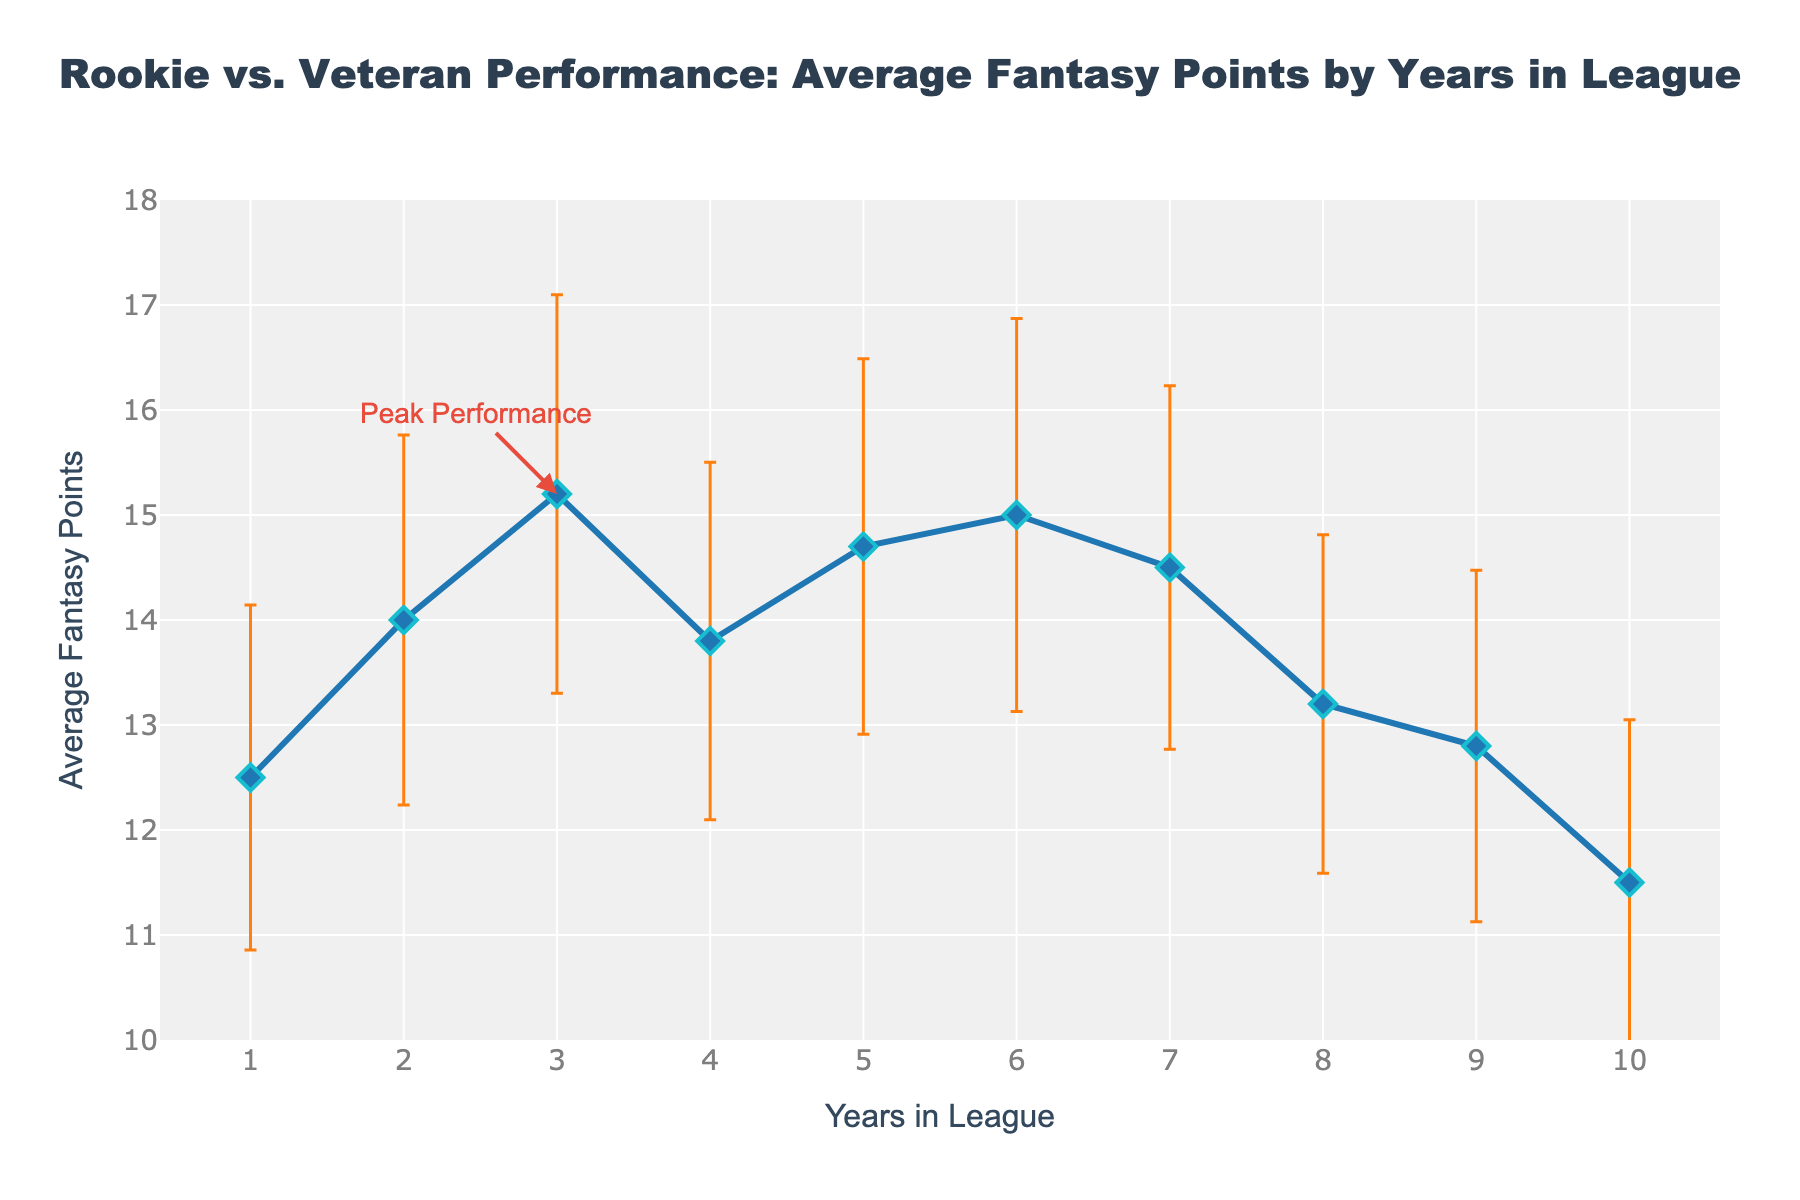what is the title of the figure? The title is prominently displayed at the top center of the figure. It reads, "Rookie vs. Veteran Performance: Average Fantasy Points by Years in League."
Answer: Rookie vs. Veteran Performance: Average Fantasy Points by Years in League What is the average fantasy points score for players in their 3rd year? The figure shows a point marked at 3 years in league with a label indicating its position on the y-axis. This point is at 15.2.
Answer: 15.2 Between which years do players exhibit peak performance in terms of average fantasy points? The figure has an annotation pointing to the peak performance at 3 years in the league, where the average fantasy points are 15.2.
Answer: 3 What is the range of average fantasy points displayed in the figure? The y-axis shows values from 10 to 18, and the data points range between approximately 11.5 and 15.2.
Answer: 11.5 to 15.2 How do the variance error bars change as players spend more years in the league? By visually examining the error bars along the x-axis, we see that the error bars are consistently visible but tend to decrease slightly after the 3rd year in the league. However, the changes are relatively small.
Answer: Slight decrease after the 3rd year What trend do the average fantasy points show over the first 4 years in the league? By observing the line and markers, average fantasy points increase in the first 3 years, peaking at 15.2, and then slightly decreasing to 13.8 in the 4th year.
Answer: Increase then slight decrease Compare the average fantasy points in the 2nd and 6th years in the league. Which year has higher average points? The figure shows data points for the 2nd and 6th years. The 2nd year is at 14.0, and the 6th year is at 15.0.
Answer: 6th year What is the variance for players in their first year and how does it visually appear in the plot? The variance for players in their first year is 2.7. The error bar, which represents the standard deviation (square root of variance), is shorter compared to other years, indicating a smaller spread.
Answer: 2.7 Which data point has the smallest average fantasy points, and what is its value? The figure shows that the 10th year has the smallest average fantasy points with a value of 11.5.
Answer: 10th year & 11.5 